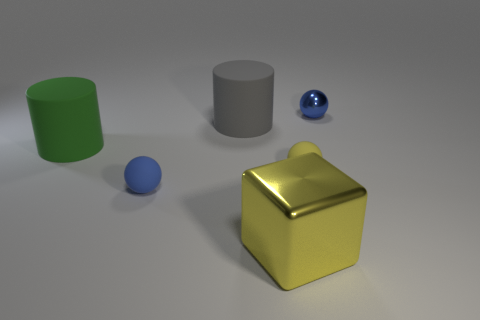Is there anything else that has the same shape as the yellow metal thing?
Your response must be concise. No. There is a matte thing that is both behind the yellow rubber ball and right of the green matte cylinder; what size is it?
Provide a succinct answer. Large. There is another tiny object that is the same color as the tiny metallic object; what is its material?
Your answer should be very brief. Rubber. What number of small spheres have the same color as the cube?
Keep it short and to the point. 1. Are there the same number of tiny blue spheres that are in front of the tiny blue metal thing and large yellow shiny objects?
Ensure brevity in your answer.  Yes. The tiny shiny object is what color?
Your answer should be compact. Blue. There is a blue object that is the same material as the green cylinder; what is its size?
Keep it short and to the point. Small. What color is the cylinder that is the same material as the large green thing?
Make the answer very short. Gray. Is there a yellow object of the same size as the green matte cylinder?
Offer a very short reply. Yes. There is a green object that is the same shape as the large gray thing; what is its material?
Your response must be concise. Rubber. 